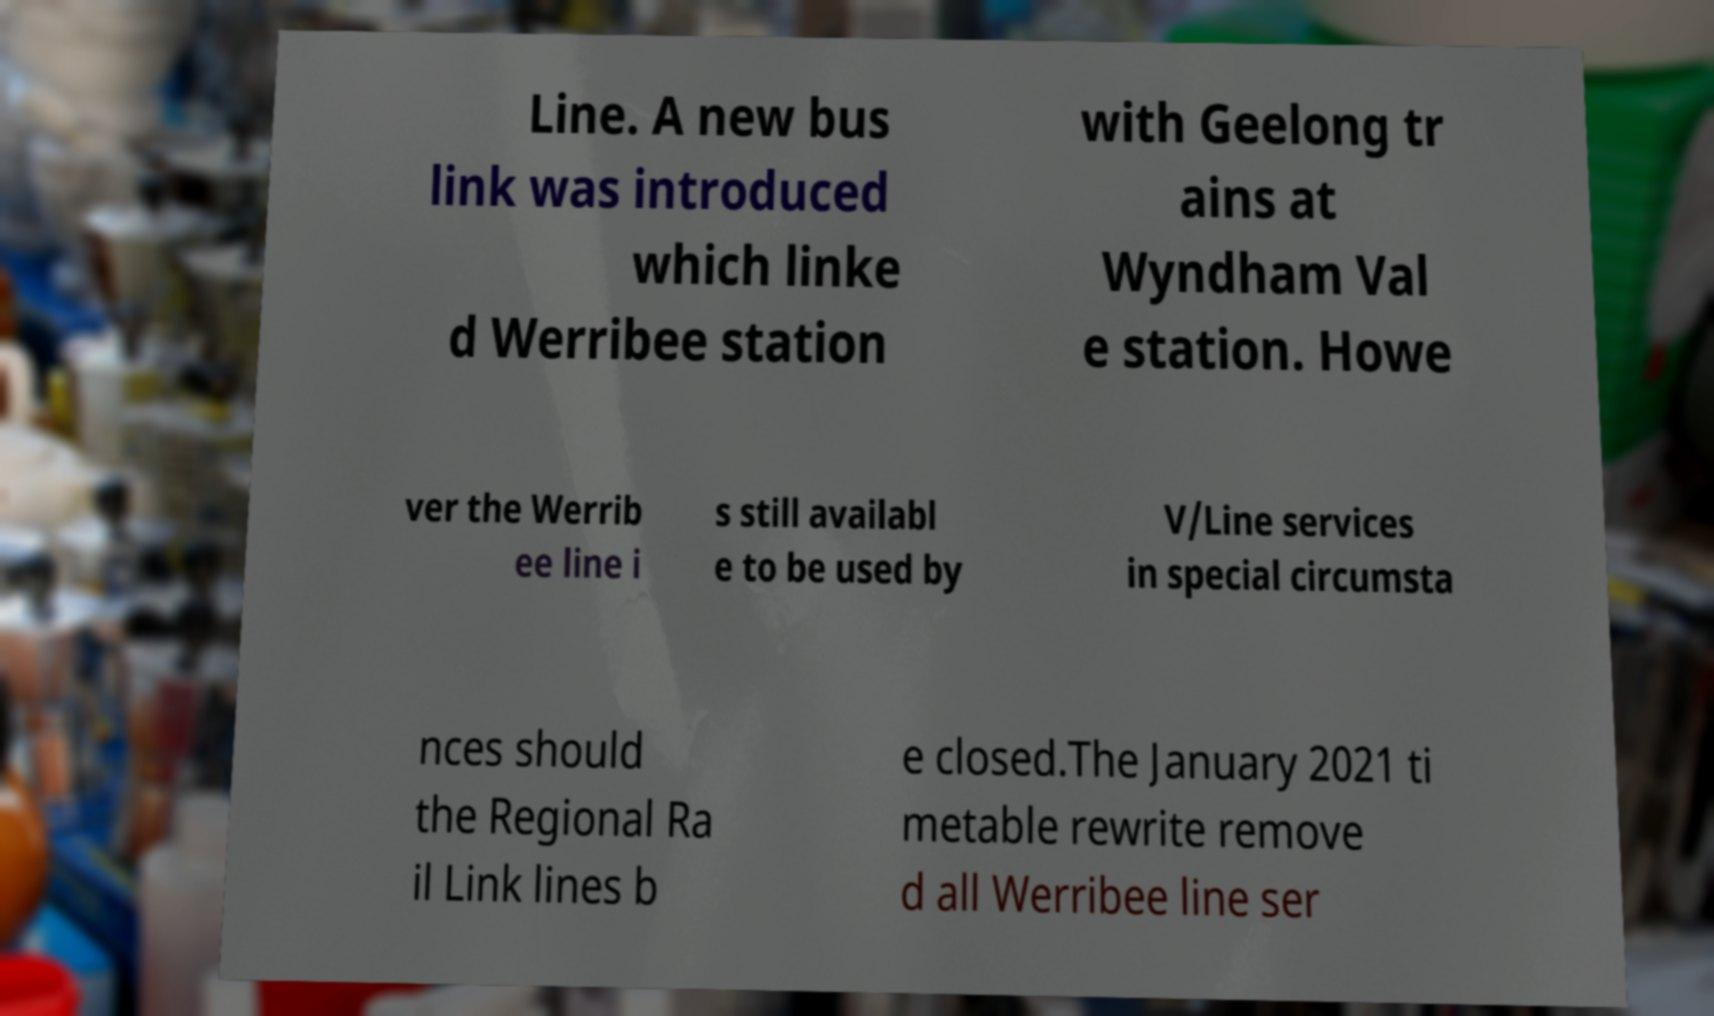Can you accurately transcribe the text from the provided image for me? Line. A new bus link was introduced which linke d Werribee station with Geelong tr ains at Wyndham Val e station. Howe ver the Werrib ee line i s still availabl e to be used by V/Line services in special circumsta nces should the Regional Ra il Link lines b e closed.The January 2021 ti metable rewrite remove d all Werribee line ser 